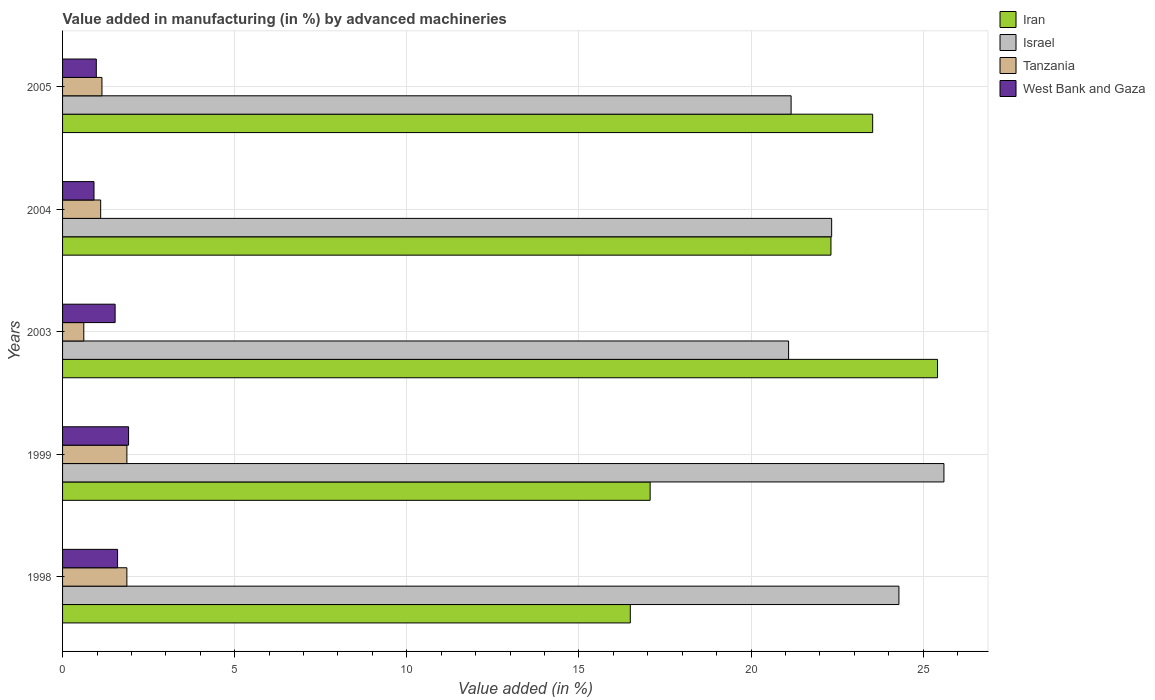How many different coloured bars are there?
Offer a very short reply. 4. How many bars are there on the 3rd tick from the bottom?
Offer a terse response. 4. In how many cases, is the number of bars for a given year not equal to the number of legend labels?
Give a very brief answer. 0. What is the percentage of value added in manufacturing by advanced machineries in Tanzania in 2004?
Your response must be concise. 1.11. Across all years, what is the maximum percentage of value added in manufacturing by advanced machineries in Israel?
Give a very brief answer. 25.6. Across all years, what is the minimum percentage of value added in manufacturing by advanced machineries in Iran?
Keep it short and to the point. 16.49. In which year was the percentage of value added in manufacturing by advanced machineries in Israel minimum?
Make the answer very short. 2003. What is the total percentage of value added in manufacturing by advanced machineries in Israel in the graph?
Offer a terse response. 114.48. What is the difference between the percentage of value added in manufacturing by advanced machineries in West Bank and Gaza in 2003 and that in 2004?
Keep it short and to the point. 0.61. What is the difference between the percentage of value added in manufacturing by advanced machineries in Israel in 2005 and the percentage of value added in manufacturing by advanced machineries in Iran in 1998?
Your answer should be compact. 4.67. What is the average percentage of value added in manufacturing by advanced machineries in West Bank and Gaza per year?
Ensure brevity in your answer.  1.39. In the year 2003, what is the difference between the percentage of value added in manufacturing by advanced machineries in Iran and percentage of value added in manufacturing by advanced machineries in West Bank and Gaza?
Offer a very short reply. 23.89. What is the ratio of the percentage of value added in manufacturing by advanced machineries in Iran in 1998 to that in 2005?
Make the answer very short. 0.7. Is the percentage of value added in manufacturing by advanced machineries in Israel in 1999 less than that in 2004?
Provide a succinct answer. No. Is the difference between the percentage of value added in manufacturing by advanced machineries in Iran in 1999 and 2005 greater than the difference between the percentage of value added in manufacturing by advanced machineries in West Bank and Gaza in 1999 and 2005?
Your answer should be very brief. No. What is the difference between the highest and the second highest percentage of value added in manufacturing by advanced machineries in Iran?
Make the answer very short. 1.88. What is the difference between the highest and the lowest percentage of value added in manufacturing by advanced machineries in Iran?
Your response must be concise. 8.92. Is the sum of the percentage of value added in manufacturing by advanced machineries in West Bank and Gaza in 1999 and 2005 greater than the maximum percentage of value added in manufacturing by advanced machineries in Israel across all years?
Offer a terse response. No. What does the 2nd bar from the top in 1999 represents?
Keep it short and to the point. Tanzania. What does the 1st bar from the bottom in 2004 represents?
Your answer should be compact. Iran. How many bars are there?
Keep it short and to the point. 20. What is the difference between two consecutive major ticks on the X-axis?
Your response must be concise. 5. Are the values on the major ticks of X-axis written in scientific E-notation?
Your answer should be compact. No. Does the graph contain grids?
Give a very brief answer. Yes. How many legend labels are there?
Make the answer very short. 4. How are the legend labels stacked?
Offer a terse response. Vertical. What is the title of the graph?
Keep it short and to the point. Value added in manufacturing (in %) by advanced machineries. What is the label or title of the X-axis?
Make the answer very short. Value added (in %). What is the Value added (in %) in Iran in 1998?
Offer a very short reply. 16.49. What is the Value added (in %) in Israel in 1998?
Your response must be concise. 24.29. What is the Value added (in %) in Tanzania in 1998?
Offer a terse response. 1.87. What is the Value added (in %) of West Bank and Gaza in 1998?
Provide a short and direct response. 1.6. What is the Value added (in %) in Iran in 1999?
Your answer should be very brief. 17.07. What is the Value added (in %) of Israel in 1999?
Give a very brief answer. 25.6. What is the Value added (in %) in Tanzania in 1999?
Offer a terse response. 1.87. What is the Value added (in %) of West Bank and Gaza in 1999?
Provide a succinct answer. 1.92. What is the Value added (in %) in Iran in 2003?
Your response must be concise. 25.41. What is the Value added (in %) in Israel in 2003?
Your answer should be very brief. 21.09. What is the Value added (in %) in Tanzania in 2003?
Offer a very short reply. 0.62. What is the Value added (in %) of West Bank and Gaza in 2003?
Keep it short and to the point. 1.53. What is the Value added (in %) of Iran in 2004?
Provide a succinct answer. 22.32. What is the Value added (in %) in Israel in 2004?
Offer a very short reply. 22.34. What is the Value added (in %) of Tanzania in 2004?
Provide a succinct answer. 1.11. What is the Value added (in %) of West Bank and Gaza in 2004?
Offer a very short reply. 0.91. What is the Value added (in %) of Iran in 2005?
Give a very brief answer. 23.53. What is the Value added (in %) of Israel in 2005?
Keep it short and to the point. 21.16. What is the Value added (in %) in Tanzania in 2005?
Your answer should be compact. 1.14. What is the Value added (in %) of West Bank and Gaza in 2005?
Provide a short and direct response. 0.98. Across all years, what is the maximum Value added (in %) in Iran?
Ensure brevity in your answer.  25.41. Across all years, what is the maximum Value added (in %) of Israel?
Your answer should be compact. 25.6. Across all years, what is the maximum Value added (in %) of Tanzania?
Provide a succinct answer. 1.87. Across all years, what is the maximum Value added (in %) in West Bank and Gaza?
Offer a very short reply. 1.92. Across all years, what is the minimum Value added (in %) of Iran?
Provide a succinct answer. 16.49. Across all years, what is the minimum Value added (in %) in Israel?
Make the answer very short. 21.09. Across all years, what is the minimum Value added (in %) of Tanzania?
Provide a short and direct response. 0.62. Across all years, what is the minimum Value added (in %) of West Bank and Gaza?
Your response must be concise. 0.91. What is the total Value added (in %) in Iran in the graph?
Keep it short and to the point. 104.82. What is the total Value added (in %) of Israel in the graph?
Give a very brief answer. 114.48. What is the total Value added (in %) of Tanzania in the graph?
Provide a short and direct response. 6.6. What is the total Value added (in %) in West Bank and Gaza in the graph?
Offer a very short reply. 6.94. What is the difference between the Value added (in %) of Iran in 1998 and that in 1999?
Provide a succinct answer. -0.58. What is the difference between the Value added (in %) in Israel in 1998 and that in 1999?
Ensure brevity in your answer.  -1.31. What is the difference between the Value added (in %) in Tanzania in 1998 and that in 1999?
Keep it short and to the point. -0. What is the difference between the Value added (in %) in West Bank and Gaza in 1998 and that in 1999?
Offer a very short reply. -0.32. What is the difference between the Value added (in %) of Iran in 1998 and that in 2003?
Ensure brevity in your answer.  -8.92. What is the difference between the Value added (in %) of Israel in 1998 and that in 2003?
Offer a very short reply. 3.2. What is the difference between the Value added (in %) in Tanzania in 1998 and that in 2003?
Make the answer very short. 1.25. What is the difference between the Value added (in %) of West Bank and Gaza in 1998 and that in 2003?
Ensure brevity in your answer.  0.07. What is the difference between the Value added (in %) of Iran in 1998 and that in 2004?
Your answer should be compact. -5.83. What is the difference between the Value added (in %) in Israel in 1998 and that in 2004?
Your answer should be very brief. 1.95. What is the difference between the Value added (in %) in Tanzania in 1998 and that in 2004?
Provide a short and direct response. 0.76. What is the difference between the Value added (in %) in West Bank and Gaza in 1998 and that in 2004?
Your answer should be very brief. 0.68. What is the difference between the Value added (in %) in Iran in 1998 and that in 2005?
Your response must be concise. -7.04. What is the difference between the Value added (in %) in Israel in 1998 and that in 2005?
Ensure brevity in your answer.  3.13. What is the difference between the Value added (in %) of Tanzania in 1998 and that in 2005?
Provide a succinct answer. 0.72. What is the difference between the Value added (in %) of West Bank and Gaza in 1998 and that in 2005?
Offer a very short reply. 0.62. What is the difference between the Value added (in %) in Iran in 1999 and that in 2003?
Your response must be concise. -8.35. What is the difference between the Value added (in %) of Israel in 1999 and that in 2003?
Offer a terse response. 4.51. What is the difference between the Value added (in %) in Tanzania in 1999 and that in 2003?
Offer a terse response. 1.25. What is the difference between the Value added (in %) in West Bank and Gaza in 1999 and that in 2003?
Your answer should be compact. 0.39. What is the difference between the Value added (in %) in Iran in 1999 and that in 2004?
Provide a succinct answer. -5.25. What is the difference between the Value added (in %) in Israel in 1999 and that in 2004?
Provide a succinct answer. 3.26. What is the difference between the Value added (in %) of Tanzania in 1999 and that in 2004?
Provide a succinct answer. 0.76. What is the difference between the Value added (in %) of Iran in 1999 and that in 2005?
Offer a terse response. -6.46. What is the difference between the Value added (in %) of Israel in 1999 and that in 2005?
Provide a short and direct response. 4.44. What is the difference between the Value added (in %) in Tanzania in 1999 and that in 2005?
Offer a terse response. 0.72. What is the difference between the Value added (in %) in West Bank and Gaza in 1999 and that in 2005?
Give a very brief answer. 0.94. What is the difference between the Value added (in %) of Iran in 2003 and that in 2004?
Your answer should be compact. 3.1. What is the difference between the Value added (in %) in Israel in 2003 and that in 2004?
Your answer should be very brief. -1.25. What is the difference between the Value added (in %) of Tanzania in 2003 and that in 2004?
Make the answer very short. -0.49. What is the difference between the Value added (in %) of West Bank and Gaza in 2003 and that in 2004?
Your answer should be compact. 0.61. What is the difference between the Value added (in %) in Iran in 2003 and that in 2005?
Ensure brevity in your answer.  1.88. What is the difference between the Value added (in %) in Israel in 2003 and that in 2005?
Your response must be concise. -0.07. What is the difference between the Value added (in %) in Tanzania in 2003 and that in 2005?
Provide a succinct answer. -0.53. What is the difference between the Value added (in %) of West Bank and Gaza in 2003 and that in 2005?
Your answer should be very brief. 0.55. What is the difference between the Value added (in %) of Iran in 2004 and that in 2005?
Your response must be concise. -1.21. What is the difference between the Value added (in %) of Israel in 2004 and that in 2005?
Ensure brevity in your answer.  1.18. What is the difference between the Value added (in %) in Tanzania in 2004 and that in 2005?
Offer a terse response. -0.04. What is the difference between the Value added (in %) in West Bank and Gaza in 2004 and that in 2005?
Make the answer very short. -0.07. What is the difference between the Value added (in %) in Iran in 1998 and the Value added (in %) in Israel in 1999?
Offer a terse response. -9.11. What is the difference between the Value added (in %) of Iran in 1998 and the Value added (in %) of Tanzania in 1999?
Your answer should be very brief. 14.62. What is the difference between the Value added (in %) in Iran in 1998 and the Value added (in %) in West Bank and Gaza in 1999?
Provide a succinct answer. 14.57. What is the difference between the Value added (in %) in Israel in 1998 and the Value added (in %) in Tanzania in 1999?
Keep it short and to the point. 22.42. What is the difference between the Value added (in %) of Israel in 1998 and the Value added (in %) of West Bank and Gaza in 1999?
Provide a short and direct response. 22.38. What is the difference between the Value added (in %) of Tanzania in 1998 and the Value added (in %) of West Bank and Gaza in 1999?
Provide a short and direct response. -0.05. What is the difference between the Value added (in %) of Iran in 1998 and the Value added (in %) of Israel in 2003?
Your answer should be compact. -4.6. What is the difference between the Value added (in %) in Iran in 1998 and the Value added (in %) in Tanzania in 2003?
Give a very brief answer. 15.87. What is the difference between the Value added (in %) of Iran in 1998 and the Value added (in %) of West Bank and Gaza in 2003?
Provide a short and direct response. 14.96. What is the difference between the Value added (in %) in Israel in 1998 and the Value added (in %) in Tanzania in 2003?
Ensure brevity in your answer.  23.68. What is the difference between the Value added (in %) in Israel in 1998 and the Value added (in %) in West Bank and Gaza in 2003?
Offer a very short reply. 22.77. What is the difference between the Value added (in %) of Tanzania in 1998 and the Value added (in %) of West Bank and Gaza in 2003?
Offer a terse response. 0.34. What is the difference between the Value added (in %) in Iran in 1998 and the Value added (in %) in Israel in 2004?
Provide a short and direct response. -5.85. What is the difference between the Value added (in %) in Iran in 1998 and the Value added (in %) in Tanzania in 2004?
Your response must be concise. 15.38. What is the difference between the Value added (in %) in Iran in 1998 and the Value added (in %) in West Bank and Gaza in 2004?
Give a very brief answer. 15.58. What is the difference between the Value added (in %) in Israel in 1998 and the Value added (in %) in Tanzania in 2004?
Provide a short and direct response. 23.19. What is the difference between the Value added (in %) in Israel in 1998 and the Value added (in %) in West Bank and Gaza in 2004?
Give a very brief answer. 23.38. What is the difference between the Value added (in %) in Tanzania in 1998 and the Value added (in %) in West Bank and Gaza in 2004?
Offer a very short reply. 0.95. What is the difference between the Value added (in %) of Iran in 1998 and the Value added (in %) of Israel in 2005?
Provide a succinct answer. -4.67. What is the difference between the Value added (in %) of Iran in 1998 and the Value added (in %) of Tanzania in 2005?
Ensure brevity in your answer.  15.35. What is the difference between the Value added (in %) in Iran in 1998 and the Value added (in %) in West Bank and Gaza in 2005?
Keep it short and to the point. 15.51. What is the difference between the Value added (in %) in Israel in 1998 and the Value added (in %) in Tanzania in 2005?
Offer a terse response. 23.15. What is the difference between the Value added (in %) in Israel in 1998 and the Value added (in %) in West Bank and Gaza in 2005?
Provide a short and direct response. 23.31. What is the difference between the Value added (in %) in Tanzania in 1998 and the Value added (in %) in West Bank and Gaza in 2005?
Offer a terse response. 0.89. What is the difference between the Value added (in %) of Iran in 1999 and the Value added (in %) of Israel in 2003?
Keep it short and to the point. -4.02. What is the difference between the Value added (in %) in Iran in 1999 and the Value added (in %) in Tanzania in 2003?
Offer a very short reply. 16.45. What is the difference between the Value added (in %) of Iran in 1999 and the Value added (in %) of West Bank and Gaza in 2003?
Give a very brief answer. 15.54. What is the difference between the Value added (in %) of Israel in 1999 and the Value added (in %) of Tanzania in 2003?
Give a very brief answer. 24.98. What is the difference between the Value added (in %) in Israel in 1999 and the Value added (in %) in West Bank and Gaza in 2003?
Ensure brevity in your answer.  24.07. What is the difference between the Value added (in %) in Tanzania in 1999 and the Value added (in %) in West Bank and Gaza in 2003?
Give a very brief answer. 0.34. What is the difference between the Value added (in %) in Iran in 1999 and the Value added (in %) in Israel in 2004?
Provide a short and direct response. -5.27. What is the difference between the Value added (in %) of Iran in 1999 and the Value added (in %) of Tanzania in 2004?
Your answer should be very brief. 15.96. What is the difference between the Value added (in %) of Iran in 1999 and the Value added (in %) of West Bank and Gaza in 2004?
Provide a short and direct response. 16.15. What is the difference between the Value added (in %) of Israel in 1999 and the Value added (in %) of Tanzania in 2004?
Provide a short and direct response. 24.49. What is the difference between the Value added (in %) in Israel in 1999 and the Value added (in %) in West Bank and Gaza in 2004?
Provide a short and direct response. 24.69. What is the difference between the Value added (in %) of Tanzania in 1999 and the Value added (in %) of West Bank and Gaza in 2004?
Give a very brief answer. 0.96. What is the difference between the Value added (in %) in Iran in 1999 and the Value added (in %) in Israel in 2005?
Offer a terse response. -4.09. What is the difference between the Value added (in %) in Iran in 1999 and the Value added (in %) in Tanzania in 2005?
Ensure brevity in your answer.  15.92. What is the difference between the Value added (in %) of Iran in 1999 and the Value added (in %) of West Bank and Gaza in 2005?
Your answer should be very brief. 16.09. What is the difference between the Value added (in %) of Israel in 1999 and the Value added (in %) of Tanzania in 2005?
Your response must be concise. 24.46. What is the difference between the Value added (in %) of Israel in 1999 and the Value added (in %) of West Bank and Gaza in 2005?
Your answer should be very brief. 24.62. What is the difference between the Value added (in %) of Tanzania in 1999 and the Value added (in %) of West Bank and Gaza in 2005?
Provide a succinct answer. 0.89. What is the difference between the Value added (in %) in Iran in 2003 and the Value added (in %) in Israel in 2004?
Offer a terse response. 3.08. What is the difference between the Value added (in %) of Iran in 2003 and the Value added (in %) of Tanzania in 2004?
Offer a terse response. 24.31. What is the difference between the Value added (in %) of Iran in 2003 and the Value added (in %) of West Bank and Gaza in 2004?
Ensure brevity in your answer.  24.5. What is the difference between the Value added (in %) in Israel in 2003 and the Value added (in %) in Tanzania in 2004?
Give a very brief answer. 19.98. What is the difference between the Value added (in %) of Israel in 2003 and the Value added (in %) of West Bank and Gaza in 2004?
Keep it short and to the point. 20.18. What is the difference between the Value added (in %) of Tanzania in 2003 and the Value added (in %) of West Bank and Gaza in 2004?
Your response must be concise. -0.3. What is the difference between the Value added (in %) in Iran in 2003 and the Value added (in %) in Israel in 2005?
Provide a short and direct response. 4.25. What is the difference between the Value added (in %) in Iran in 2003 and the Value added (in %) in Tanzania in 2005?
Your answer should be very brief. 24.27. What is the difference between the Value added (in %) of Iran in 2003 and the Value added (in %) of West Bank and Gaza in 2005?
Your answer should be very brief. 24.43. What is the difference between the Value added (in %) in Israel in 2003 and the Value added (in %) in Tanzania in 2005?
Your answer should be compact. 19.94. What is the difference between the Value added (in %) of Israel in 2003 and the Value added (in %) of West Bank and Gaza in 2005?
Provide a short and direct response. 20.11. What is the difference between the Value added (in %) in Tanzania in 2003 and the Value added (in %) in West Bank and Gaza in 2005?
Your answer should be very brief. -0.36. What is the difference between the Value added (in %) of Iran in 2004 and the Value added (in %) of Israel in 2005?
Make the answer very short. 1.16. What is the difference between the Value added (in %) of Iran in 2004 and the Value added (in %) of Tanzania in 2005?
Keep it short and to the point. 21.17. What is the difference between the Value added (in %) of Iran in 2004 and the Value added (in %) of West Bank and Gaza in 2005?
Offer a very short reply. 21.34. What is the difference between the Value added (in %) in Israel in 2004 and the Value added (in %) in Tanzania in 2005?
Make the answer very short. 21.2. What is the difference between the Value added (in %) in Israel in 2004 and the Value added (in %) in West Bank and Gaza in 2005?
Provide a succinct answer. 21.36. What is the difference between the Value added (in %) in Tanzania in 2004 and the Value added (in %) in West Bank and Gaza in 2005?
Provide a succinct answer. 0.13. What is the average Value added (in %) of Iran per year?
Offer a terse response. 20.96. What is the average Value added (in %) of Israel per year?
Make the answer very short. 22.9. What is the average Value added (in %) of Tanzania per year?
Your response must be concise. 1.32. What is the average Value added (in %) in West Bank and Gaza per year?
Ensure brevity in your answer.  1.39. In the year 1998, what is the difference between the Value added (in %) of Iran and Value added (in %) of Israel?
Provide a succinct answer. -7.8. In the year 1998, what is the difference between the Value added (in %) of Iran and Value added (in %) of Tanzania?
Your answer should be very brief. 14.62. In the year 1998, what is the difference between the Value added (in %) of Iran and Value added (in %) of West Bank and Gaza?
Provide a short and direct response. 14.89. In the year 1998, what is the difference between the Value added (in %) in Israel and Value added (in %) in Tanzania?
Your answer should be compact. 22.42. In the year 1998, what is the difference between the Value added (in %) in Israel and Value added (in %) in West Bank and Gaza?
Your answer should be compact. 22.7. In the year 1998, what is the difference between the Value added (in %) of Tanzania and Value added (in %) of West Bank and Gaza?
Provide a succinct answer. 0.27. In the year 1999, what is the difference between the Value added (in %) of Iran and Value added (in %) of Israel?
Provide a short and direct response. -8.53. In the year 1999, what is the difference between the Value added (in %) in Iran and Value added (in %) in Tanzania?
Ensure brevity in your answer.  15.2. In the year 1999, what is the difference between the Value added (in %) of Iran and Value added (in %) of West Bank and Gaza?
Keep it short and to the point. 15.15. In the year 1999, what is the difference between the Value added (in %) in Israel and Value added (in %) in Tanzania?
Give a very brief answer. 23.73. In the year 1999, what is the difference between the Value added (in %) in Israel and Value added (in %) in West Bank and Gaza?
Offer a very short reply. 23.68. In the year 1999, what is the difference between the Value added (in %) in Tanzania and Value added (in %) in West Bank and Gaza?
Your response must be concise. -0.05. In the year 2003, what is the difference between the Value added (in %) in Iran and Value added (in %) in Israel?
Your response must be concise. 4.33. In the year 2003, what is the difference between the Value added (in %) in Iran and Value added (in %) in Tanzania?
Your response must be concise. 24.8. In the year 2003, what is the difference between the Value added (in %) in Iran and Value added (in %) in West Bank and Gaza?
Offer a terse response. 23.89. In the year 2003, what is the difference between the Value added (in %) of Israel and Value added (in %) of Tanzania?
Provide a succinct answer. 20.47. In the year 2003, what is the difference between the Value added (in %) of Israel and Value added (in %) of West Bank and Gaza?
Make the answer very short. 19.56. In the year 2003, what is the difference between the Value added (in %) in Tanzania and Value added (in %) in West Bank and Gaza?
Keep it short and to the point. -0.91. In the year 2004, what is the difference between the Value added (in %) of Iran and Value added (in %) of Israel?
Make the answer very short. -0.02. In the year 2004, what is the difference between the Value added (in %) of Iran and Value added (in %) of Tanzania?
Your answer should be very brief. 21.21. In the year 2004, what is the difference between the Value added (in %) of Iran and Value added (in %) of West Bank and Gaza?
Offer a very short reply. 21.41. In the year 2004, what is the difference between the Value added (in %) in Israel and Value added (in %) in Tanzania?
Your answer should be very brief. 21.23. In the year 2004, what is the difference between the Value added (in %) in Israel and Value added (in %) in West Bank and Gaza?
Ensure brevity in your answer.  21.43. In the year 2004, what is the difference between the Value added (in %) in Tanzania and Value added (in %) in West Bank and Gaza?
Ensure brevity in your answer.  0.19. In the year 2005, what is the difference between the Value added (in %) in Iran and Value added (in %) in Israel?
Provide a succinct answer. 2.37. In the year 2005, what is the difference between the Value added (in %) of Iran and Value added (in %) of Tanzania?
Your answer should be compact. 22.39. In the year 2005, what is the difference between the Value added (in %) in Iran and Value added (in %) in West Bank and Gaza?
Your answer should be compact. 22.55. In the year 2005, what is the difference between the Value added (in %) of Israel and Value added (in %) of Tanzania?
Make the answer very short. 20.02. In the year 2005, what is the difference between the Value added (in %) in Israel and Value added (in %) in West Bank and Gaza?
Your response must be concise. 20.18. In the year 2005, what is the difference between the Value added (in %) in Tanzania and Value added (in %) in West Bank and Gaza?
Your answer should be very brief. 0.16. What is the ratio of the Value added (in %) of Iran in 1998 to that in 1999?
Provide a short and direct response. 0.97. What is the ratio of the Value added (in %) of Israel in 1998 to that in 1999?
Provide a succinct answer. 0.95. What is the ratio of the Value added (in %) in Tanzania in 1998 to that in 1999?
Offer a very short reply. 1. What is the ratio of the Value added (in %) of Iran in 1998 to that in 2003?
Make the answer very short. 0.65. What is the ratio of the Value added (in %) of Israel in 1998 to that in 2003?
Keep it short and to the point. 1.15. What is the ratio of the Value added (in %) in Tanzania in 1998 to that in 2003?
Provide a succinct answer. 3.03. What is the ratio of the Value added (in %) in West Bank and Gaza in 1998 to that in 2003?
Provide a succinct answer. 1.05. What is the ratio of the Value added (in %) of Iran in 1998 to that in 2004?
Keep it short and to the point. 0.74. What is the ratio of the Value added (in %) of Israel in 1998 to that in 2004?
Your answer should be compact. 1.09. What is the ratio of the Value added (in %) of Tanzania in 1998 to that in 2004?
Your response must be concise. 1.69. What is the ratio of the Value added (in %) of West Bank and Gaza in 1998 to that in 2004?
Give a very brief answer. 1.75. What is the ratio of the Value added (in %) of Iran in 1998 to that in 2005?
Your answer should be very brief. 0.7. What is the ratio of the Value added (in %) of Israel in 1998 to that in 2005?
Your response must be concise. 1.15. What is the ratio of the Value added (in %) of Tanzania in 1998 to that in 2005?
Your answer should be compact. 1.63. What is the ratio of the Value added (in %) in West Bank and Gaza in 1998 to that in 2005?
Provide a short and direct response. 1.63. What is the ratio of the Value added (in %) in Iran in 1999 to that in 2003?
Offer a very short reply. 0.67. What is the ratio of the Value added (in %) of Israel in 1999 to that in 2003?
Offer a very short reply. 1.21. What is the ratio of the Value added (in %) of Tanzania in 1999 to that in 2003?
Your response must be concise. 3.03. What is the ratio of the Value added (in %) of West Bank and Gaza in 1999 to that in 2003?
Offer a very short reply. 1.26. What is the ratio of the Value added (in %) of Iran in 1999 to that in 2004?
Offer a terse response. 0.76. What is the ratio of the Value added (in %) in Israel in 1999 to that in 2004?
Provide a succinct answer. 1.15. What is the ratio of the Value added (in %) in Tanzania in 1999 to that in 2004?
Your answer should be very brief. 1.69. What is the ratio of the Value added (in %) of West Bank and Gaza in 1999 to that in 2004?
Keep it short and to the point. 2.1. What is the ratio of the Value added (in %) of Iran in 1999 to that in 2005?
Provide a succinct answer. 0.73. What is the ratio of the Value added (in %) in Israel in 1999 to that in 2005?
Your answer should be very brief. 1.21. What is the ratio of the Value added (in %) of Tanzania in 1999 to that in 2005?
Your answer should be very brief. 1.63. What is the ratio of the Value added (in %) in West Bank and Gaza in 1999 to that in 2005?
Make the answer very short. 1.96. What is the ratio of the Value added (in %) of Iran in 2003 to that in 2004?
Provide a succinct answer. 1.14. What is the ratio of the Value added (in %) in Israel in 2003 to that in 2004?
Make the answer very short. 0.94. What is the ratio of the Value added (in %) in Tanzania in 2003 to that in 2004?
Give a very brief answer. 0.56. What is the ratio of the Value added (in %) in West Bank and Gaza in 2003 to that in 2004?
Your answer should be compact. 1.67. What is the ratio of the Value added (in %) in Iran in 2003 to that in 2005?
Offer a terse response. 1.08. What is the ratio of the Value added (in %) in Israel in 2003 to that in 2005?
Ensure brevity in your answer.  1. What is the ratio of the Value added (in %) of Tanzania in 2003 to that in 2005?
Your answer should be compact. 0.54. What is the ratio of the Value added (in %) in West Bank and Gaza in 2003 to that in 2005?
Provide a succinct answer. 1.56. What is the ratio of the Value added (in %) of Iran in 2004 to that in 2005?
Your answer should be very brief. 0.95. What is the ratio of the Value added (in %) in Israel in 2004 to that in 2005?
Your answer should be very brief. 1.06. What is the ratio of the Value added (in %) in Tanzania in 2004 to that in 2005?
Provide a succinct answer. 0.97. What is the ratio of the Value added (in %) in West Bank and Gaza in 2004 to that in 2005?
Provide a succinct answer. 0.93. What is the difference between the highest and the second highest Value added (in %) in Iran?
Your answer should be very brief. 1.88. What is the difference between the highest and the second highest Value added (in %) of Israel?
Provide a succinct answer. 1.31. What is the difference between the highest and the second highest Value added (in %) of West Bank and Gaza?
Ensure brevity in your answer.  0.32. What is the difference between the highest and the lowest Value added (in %) of Iran?
Keep it short and to the point. 8.92. What is the difference between the highest and the lowest Value added (in %) in Israel?
Offer a terse response. 4.51. What is the difference between the highest and the lowest Value added (in %) of Tanzania?
Provide a succinct answer. 1.25. 